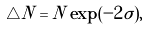<formula> <loc_0><loc_0><loc_500><loc_500>\triangle N = N \exp ( - 2 \tilde { \sigma } ) ,</formula> 